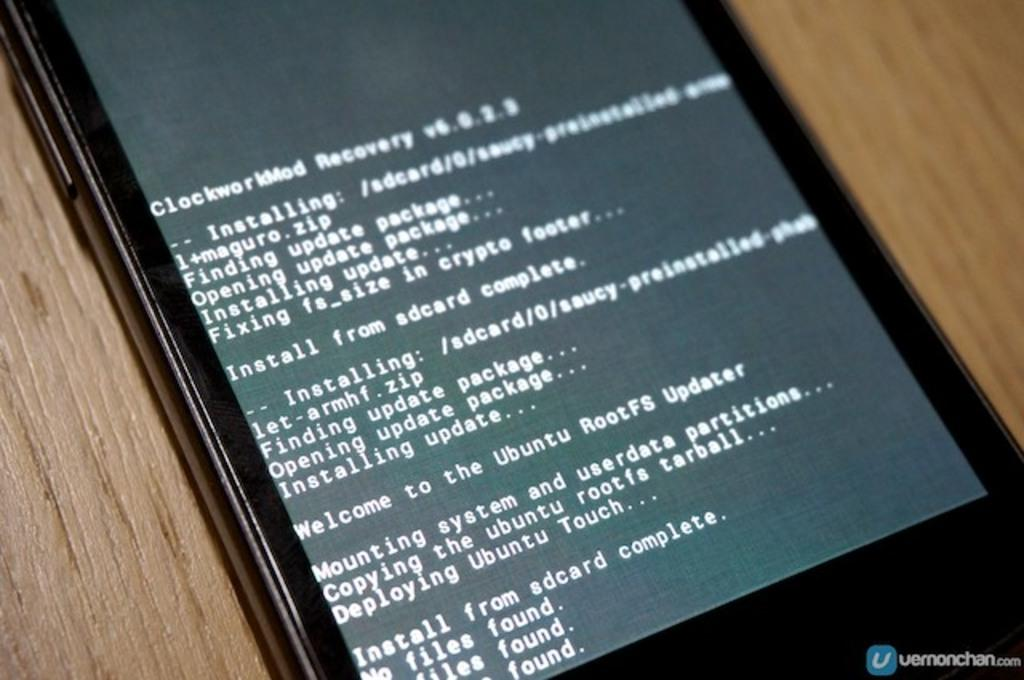<image>
Create a compact narrative representing the image presented. A tablet with white text saying things about installing and copying 